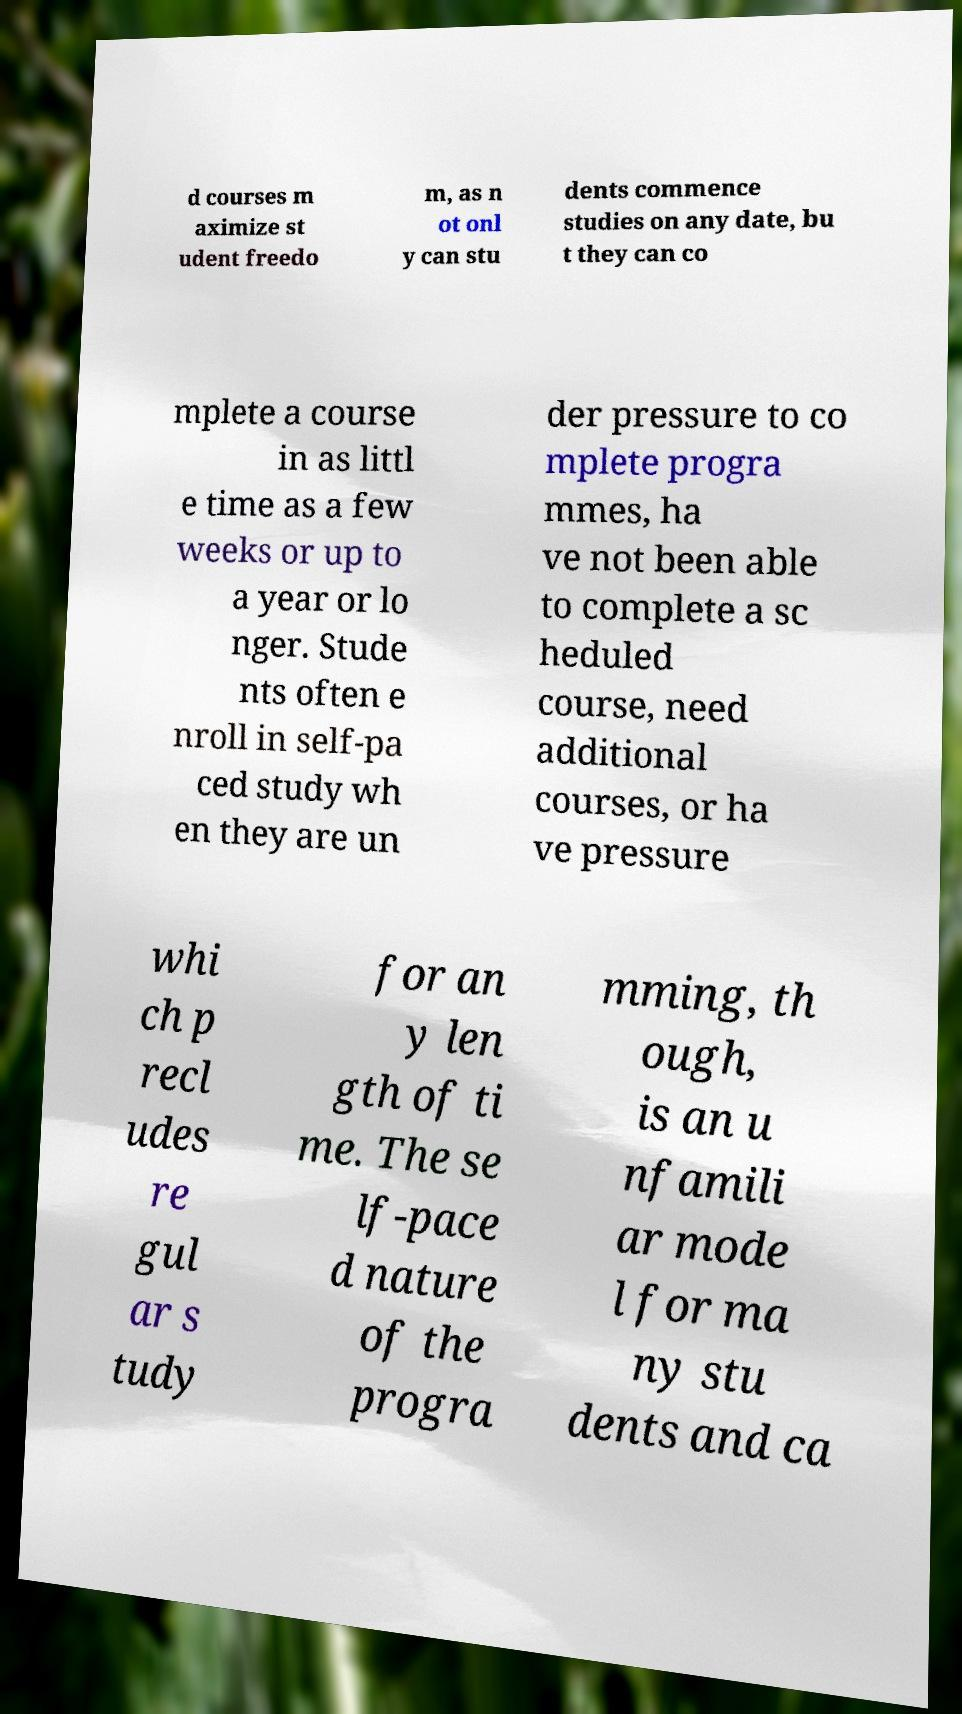What messages or text are displayed in this image? I need them in a readable, typed format. d courses m aximize st udent freedo m, as n ot onl y can stu dents commence studies on any date, bu t they can co mplete a course in as littl e time as a few weeks or up to a year or lo nger. Stude nts often e nroll in self-pa ced study wh en they are un der pressure to co mplete progra mmes, ha ve not been able to complete a sc heduled course, need additional courses, or ha ve pressure whi ch p recl udes re gul ar s tudy for an y len gth of ti me. The se lf-pace d nature of the progra mming, th ough, is an u nfamili ar mode l for ma ny stu dents and ca 